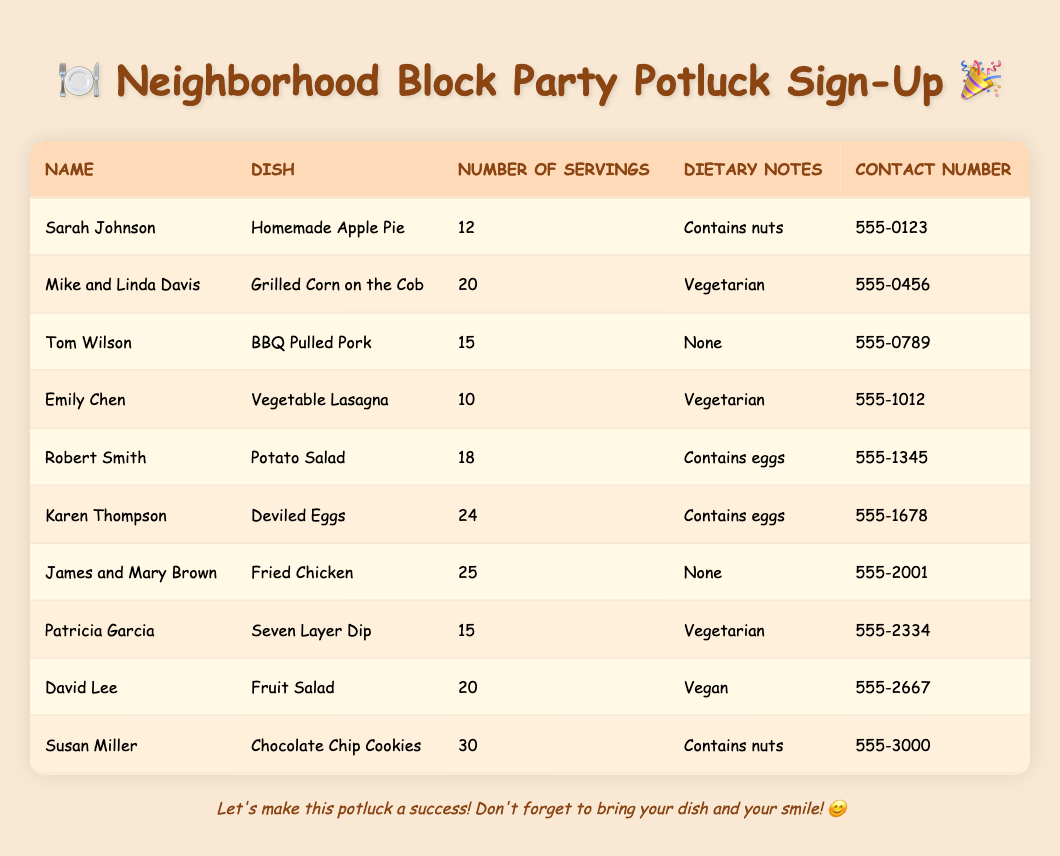What dish does Sarah Johnson bring to the potluck? Sarah Johnson is listed under the "Name" column, and in the same row under the "Dish" column, she has "Homemade Apple Pie" as her contribution.
Answer: Homemade Apple Pie How many servings does Mike and Linda Davis provide? In the row for Mike and Linda Davis, the "Number of Servings" column indicates that they are bringing 20 servings.
Answer: 20 Which dishes are marked as vegetarian? Looking through the "Dish" column, the vegetarian options are "Grilled Corn on the Cob," "Vegetable Lasagna," and "Seven Layer Dip," which correspond to Mike and Linda Davis, Emily Chen, and Patricia Garcia, respectively.
Answer: Grilled Corn on the Cob, Vegetable Lasagna, Seven Layer Dip What is the total number of servings contributed by all participants? To find the total, we add up all the servings listed: 12 + 20 + 15 + 10 + 18 + 24 + 25 + 15 + 20 + 30 =  12 + 20 + 15 + 10 + 18 + 24 + 25 + 15 + 20 + 30 =  5 + 18 + 24 + 25 + 20 + 30 = 18 + 55 + 5 =  10 = 1 + 52 = 10 = 10 = 5 + 40 = 10 = 1 =  2 + 30 + 30 =  6 = 5 = 175
Answer: 175 Is there any dish containing nuts? Looking through the "Dietary Notes" column, we see that the dishes "Homemade Apple Pie" by Sarah Johnson and "Chocolate Chip Cookies" by Susan Miller both contain nuts, confirming that there are dishes with this ingredient.
Answer: Yes What is the average number of servings per dish? First, we find the total number of servings, which is 175, and then divide it by the number of dishes, which is 10 (there are 10 rows of dishes). Thus, the average is 175/10 = 17.5.
Answer: 17.5 Which contact number belongs to Robert Smith? In the table, Robert Smith is listed under the "Name" column, and looking across that row, the "Contact Number" column shows his number is 555-1345.
Answer: 555-1345 How many dishes are there that contain eggs? Examining the "Dietary Notes" column, we see that "Potato Salad" and "Deviled Eggs" both mention containing eggs, indicating that there are two dishes with this note.
Answer: 2 Which dish has the highest number of servings? To determine the dish with the highest servings, we check the "Number of Servings" column for the largest number. "Deviled Eggs" by Karen Thompson has 24 servings, which is the maximum observed in the table.
Answer: Deviled Eggs 